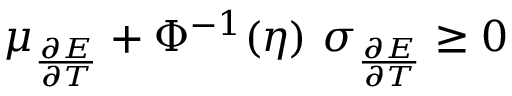Convert formula to latex. <formula><loc_0><loc_0><loc_500><loc_500>\mu _ { \frac { \partial E } { \partial T } } + \Phi ^ { - 1 } ( \eta ) \ \sigma _ { \frac { \partial E } { \partial T } } \geq 0</formula> 